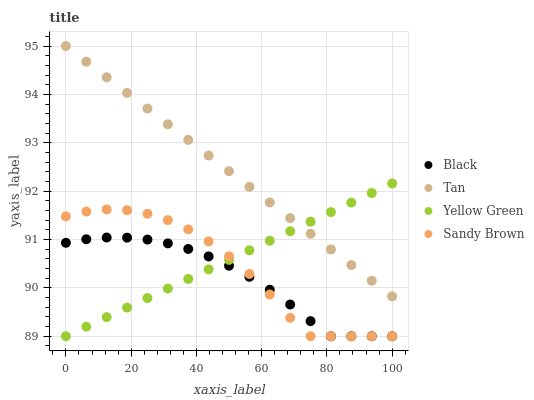Does Black have the minimum area under the curve?
Answer yes or no. Yes. Does Tan have the maximum area under the curve?
Answer yes or no. Yes. Does Tan have the minimum area under the curve?
Answer yes or no. No. Does Black have the maximum area under the curve?
Answer yes or no. No. Is Yellow Green the smoothest?
Answer yes or no. Yes. Is Sandy Brown the roughest?
Answer yes or no. Yes. Is Tan the smoothest?
Answer yes or no. No. Is Tan the roughest?
Answer yes or no. No. Does Sandy Brown have the lowest value?
Answer yes or no. Yes. Does Tan have the lowest value?
Answer yes or no. No. Does Tan have the highest value?
Answer yes or no. Yes. Does Black have the highest value?
Answer yes or no. No. Is Sandy Brown less than Tan?
Answer yes or no. Yes. Is Tan greater than Sandy Brown?
Answer yes or no. Yes. Does Yellow Green intersect Black?
Answer yes or no. Yes. Is Yellow Green less than Black?
Answer yes or no. No. Is Yellow Green greater than Black?
Answer yes or no. No. Does Sandy Brown intersect Tan?
Answer yes or no. No. 